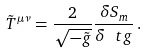<formula> <loc_0><loc_0><loc_500><loc_500>\tilde { T } ^ { \mu \nu } = \frac { 2 } { \sqrt { - \tilde { g } } } \frac { \delta S _ { m } } { \delta \ t g } \, .</formula> 